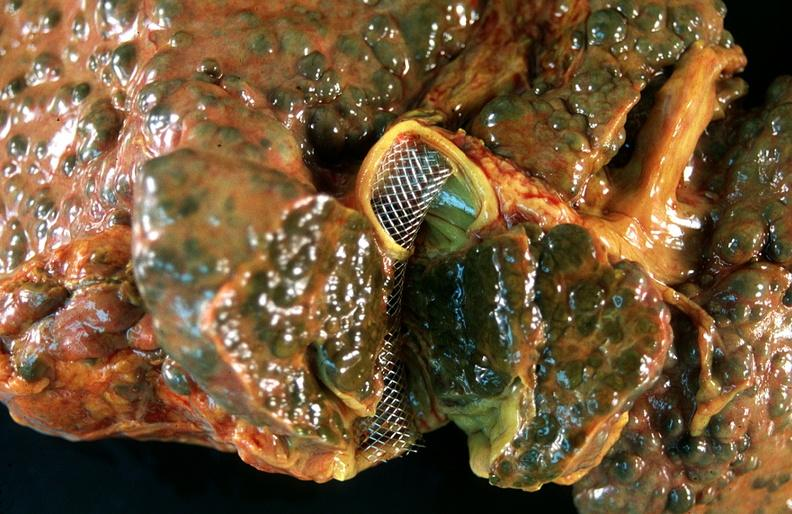does endometritis show liver, macronodular cirrhosis, hcv - transjugular intrahepatic portocaval shunt tips?
Answer the question using a single word or phrase. No 